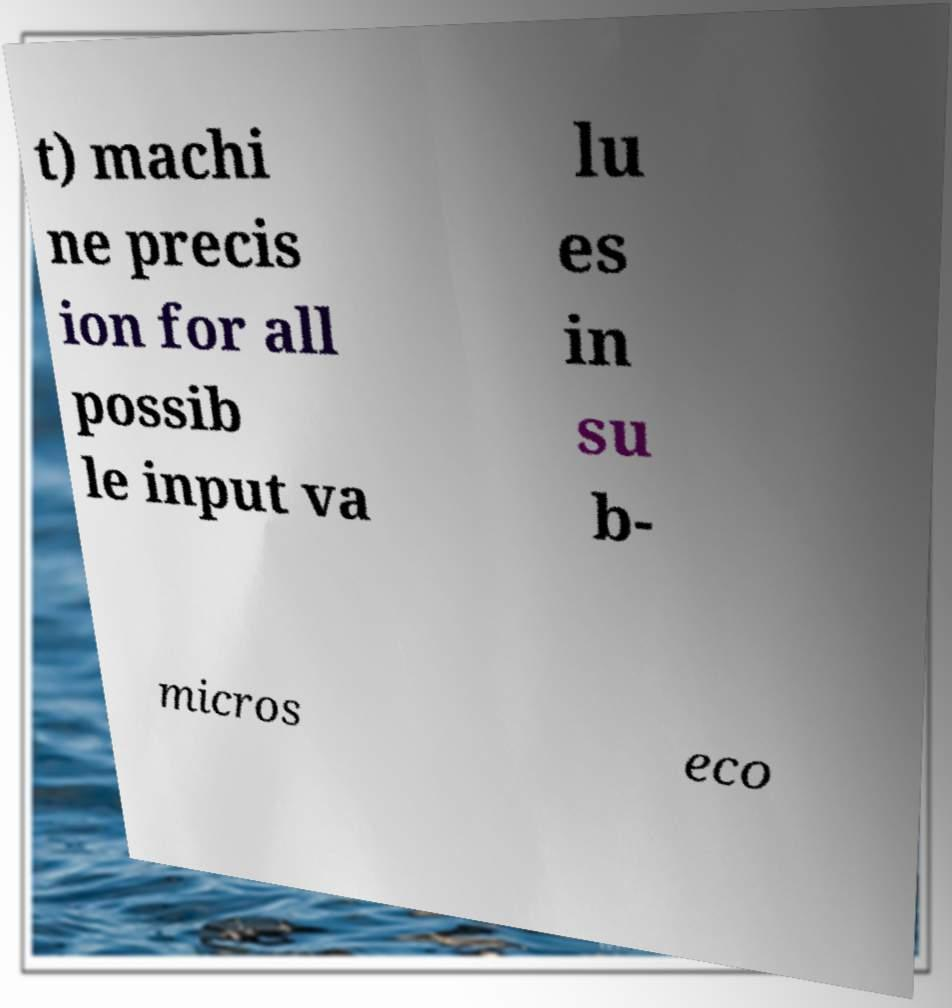Can you accurately transcribe the text from the provided image for me? t) machi ne precis ion for all possib le input va lu es in su b- micros eco 